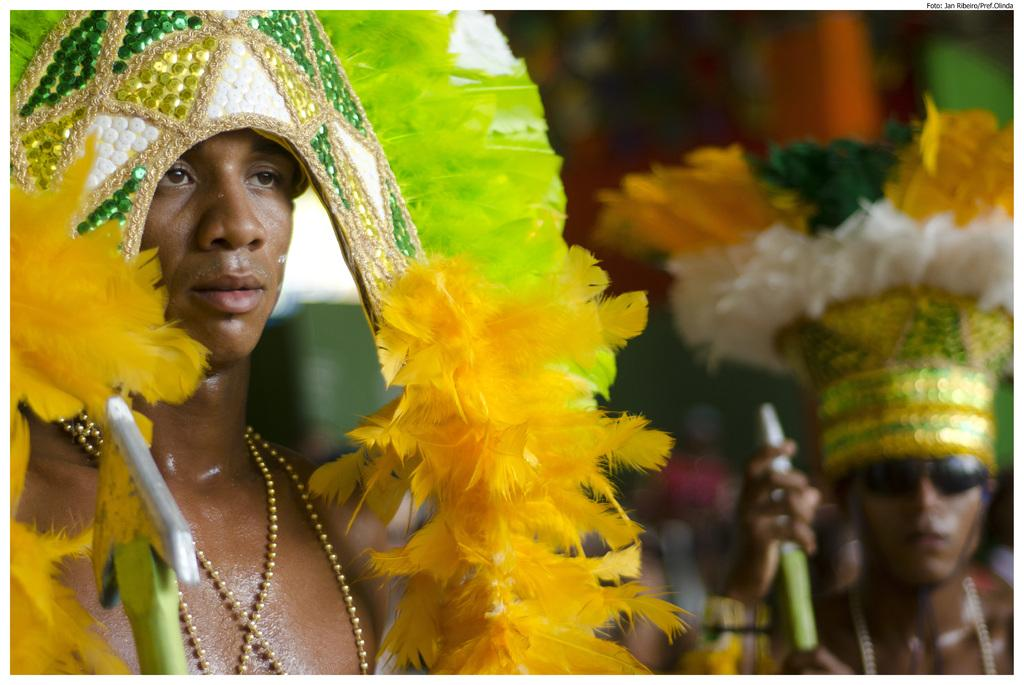Who is on the left side of the image? There is a man on the left side of the image. Who is on the right side of the image? There is another person on the right side of the image. Can you describe the background of the image? The background of the image is blurred. What type of curtain is hanging on the left side of the image? There is no curtain present in the image. What is the person on the right side of the image using to write in the image? There is no pen or writing activity depicted in the image. 